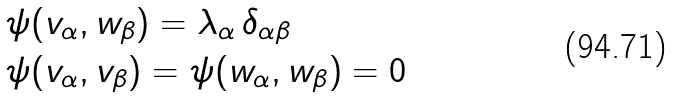Convert formula to latex. <formula><loc_0><loc_0><loc_500><loc_500>& \psi ( v _ { \alpha } , w _ { \beta } ) = \lambda _ { \alpha } \, \delta _ { \alpha \beta } \\ & \psi ( v _ { \alpha } , v _ { \beta } ) = \psi ( w _ { \alpha } , w _ { \beta } ) = 0</formula> 